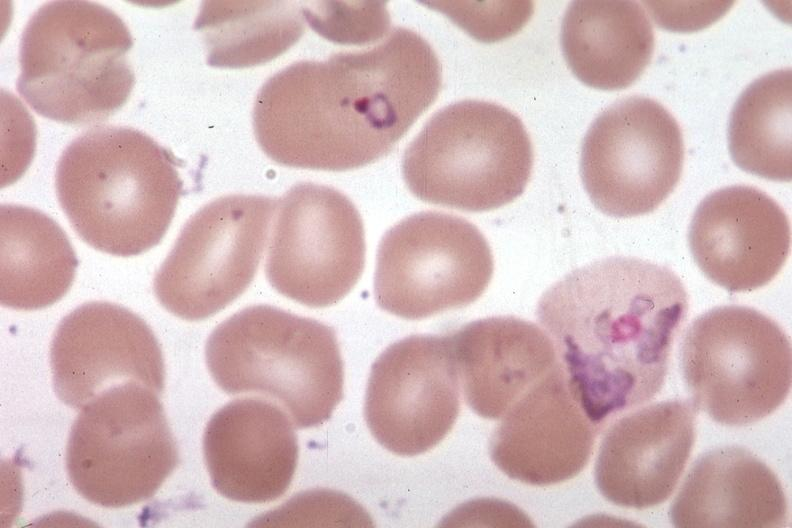s splenomegaly with cirrhosis present?
Answer the question using a single word or phrase. No 